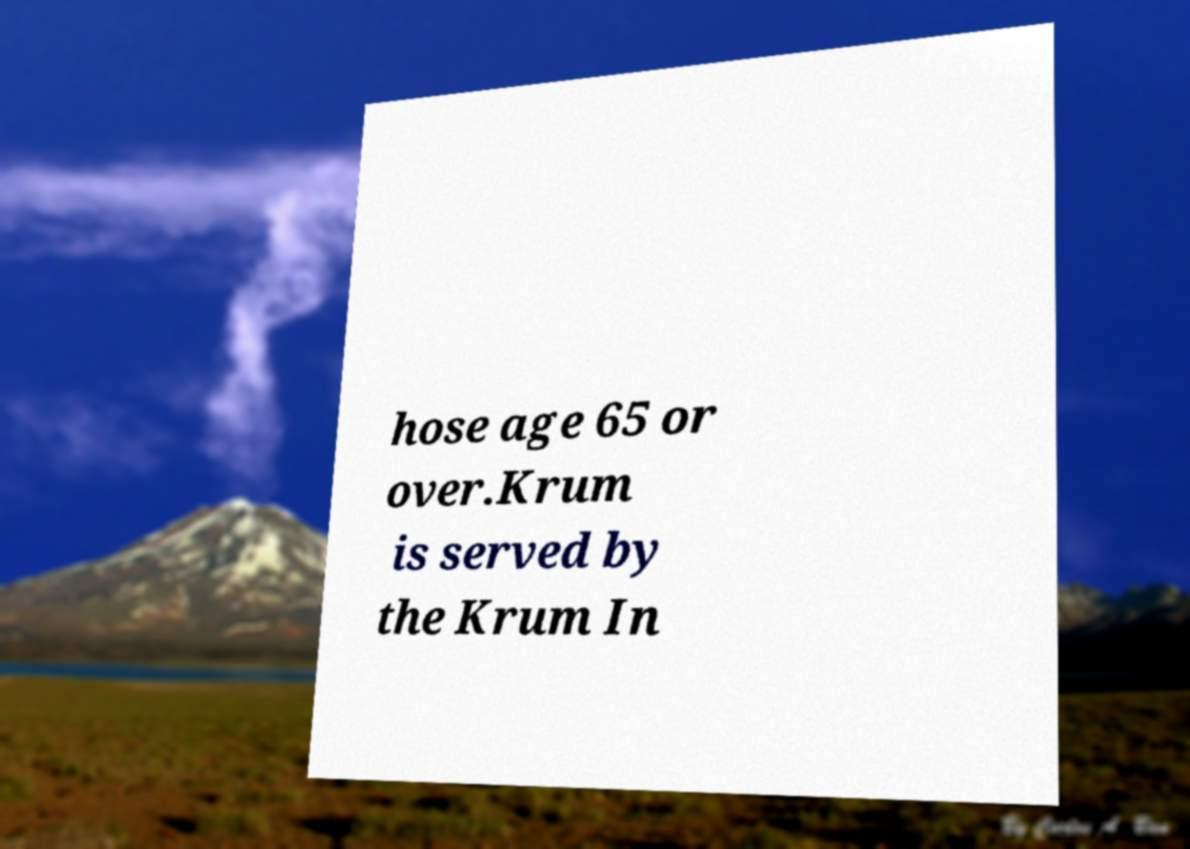Please read and relay the text visible in this image. What does it say? hose age 65 or over.Krum is served by the Krum In 